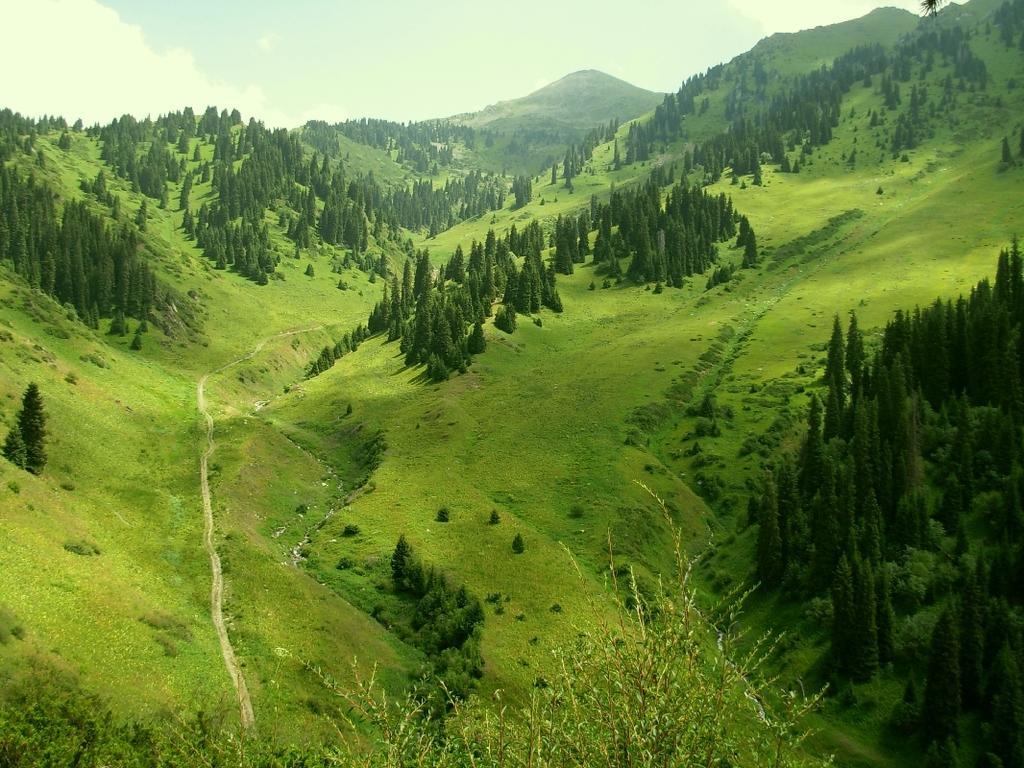Please provide a concise description of this image. In this image we can see mountains full of grass and trees. The sky is covered with clouds. 